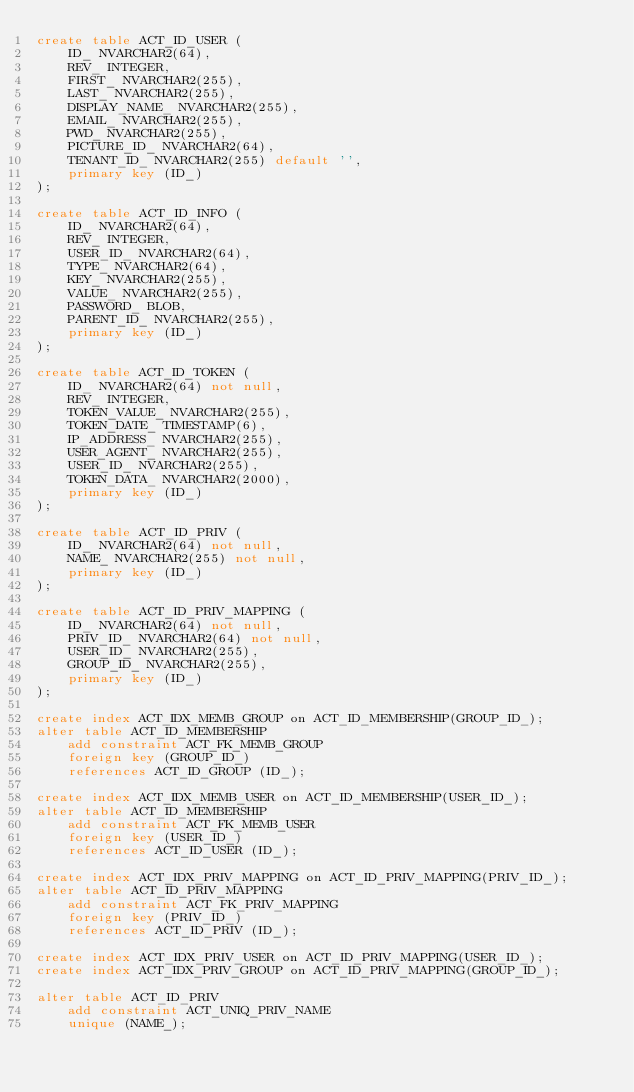Convert code to text. <code><loc_0><loc_0><loc_500><loc_500><_SQL_>create table ACT_ID_USER (
    ID_ NVARCHAR2(64),
    REV_ INTEGER,
    FIRST_ NVARCHAR2(255),
    LAST_ NVARCHAR2(255),
    DISPLAY_NAME_ NVARCHAR2(255),
    EMAIL_ NVARCHAR2(255),
    PWD_ NVARCHAR2(255),
    PICTURE_ID_ NVARCHAR2(64),
    TENANT_ID_ NVARCHAR2(255) default '',
    primary key (ID_)
);

create table ACT_ID_INFO (
    ID_ NVARCHAR2(64),
    REV_ INTEGER,
    USER_ID_ NVARCHAR2(64),
    TYPE_ NVARCHAR2(64),
    KEY_ NVARCHAR2(255),
    VALUE_ NVARCHAR2(255),
    PASSWORD_ BLOB,
    PARENT_ID_ NVARCHAR2(255),
    primary key (ID_)
);

create table ACT_ID_TOKEN (
    ID_ NVARCHAR2(64) not null,
    REV_ INTEGER,
    TOKEN_VALUE_ NVARCHAR2(255),
    TOKEN_DATE_ TIMESTAMP(6),
    IP_ADDRESS_ NVARCHAR2(255),
    USER_AGENT_ NVARCHAR2(255),
    USER_ID_ NVARCHAR2(255),
    TOKEN_DATA_ NVARCHAR2(2000),
    primary key (ID_)
);

create table ACT_ID_PRIV (
    ID_ NVARCHAR2(64) not null,
    NAME_ NVARCHAR2(255) not null,
    primary key (ID_)
);

create table ACT_ID_PRIV_MAPPING (
    ID_ NVARCHAR2(64) not null,
    PRIV_ID_ NVARCHAR2(64) not null,
    USER_ID_ NVARCHAR2(255),
    GROUP_ID_ NVARCHAR2(255),
    primary key (ID_)
);

create index ACT_IDX_MEMB_GROUP on ACT_ID_MEMBERSHIP(GROUP_ID_);
alter table ACT_ID_MEMBERSHIP
    add constraint ACT_FK_MEMB_GROUP
    foreign key (GROUP_ID_)
    references ACT_ID_GROUP (ID_);

create index ACT_IDX_MEMB_USER on ACT_ID_MEMBERSHIP(USER_ID_);
alter table ACT_ID_MEMBERSHIP
    add constraint ACT_FK_MEMB_USER
    foreign key (USER_ID_)
    references ACT_ID_USER (ID_);

create index ACT_IDX_PRIV_MAPPING on ACT_ID_PRIV_MAPPING(PRIV_ID_);
alter table ACT_ID_PRIV_MAPPING
    add constraint ACT_FK_PRIV_MAPPING
    foreign key (PRIV_ID_)
    references ACT_ID_PRIV (ID_);

create index ACT_IDX_PRIV_USER on ACT_ID_PRIV_MAPPING(USER_ID_);
create index ACT_IDX_PRIV_GROUP on ACT_ID_PRIV_MAPPING(GROUP_ID_);

alter table ACT_ID_PRIV
    add constraint ACT_UNIQ_PRIV_NAME
    unique (NAME_);
</code> 